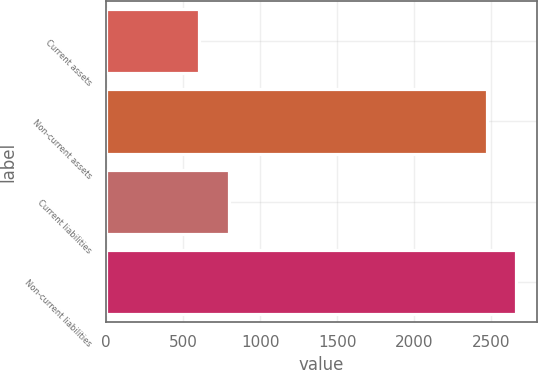Convert chart. <chart><loc_0><loc_0><loc_500><loc_500><bar_chart><fcel>Current assets<fcel>Non-current assets<fcel>Current liabilities<fcel>Non-current liabilities<nl><fcel>605<fcel>2470<fcel>797.9<fcel>2662.9<nl></chart> 